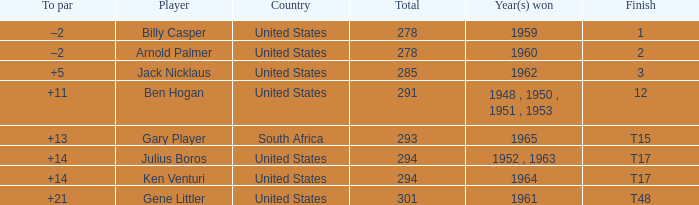What is Country, when Year(s) Won is "1962"? United States. 